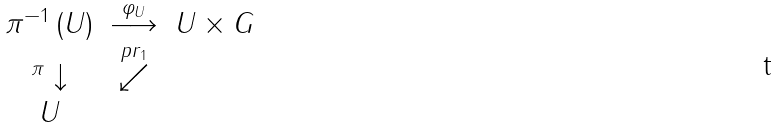Convert formula to latex. <formula><loc_0><loc_0><loc_500><loc_500>\begin{array} { c c c } \pi ^ { - 1 } \left ( U \right ) & \stackrel { \varphi _ { U } } { \longrightarrow } & U \times G \\ ^ { \pi } \downarrow & \stackrel { p r _ { 1 } } { \swarrow } & \\ U & & \end{array}</formula> 